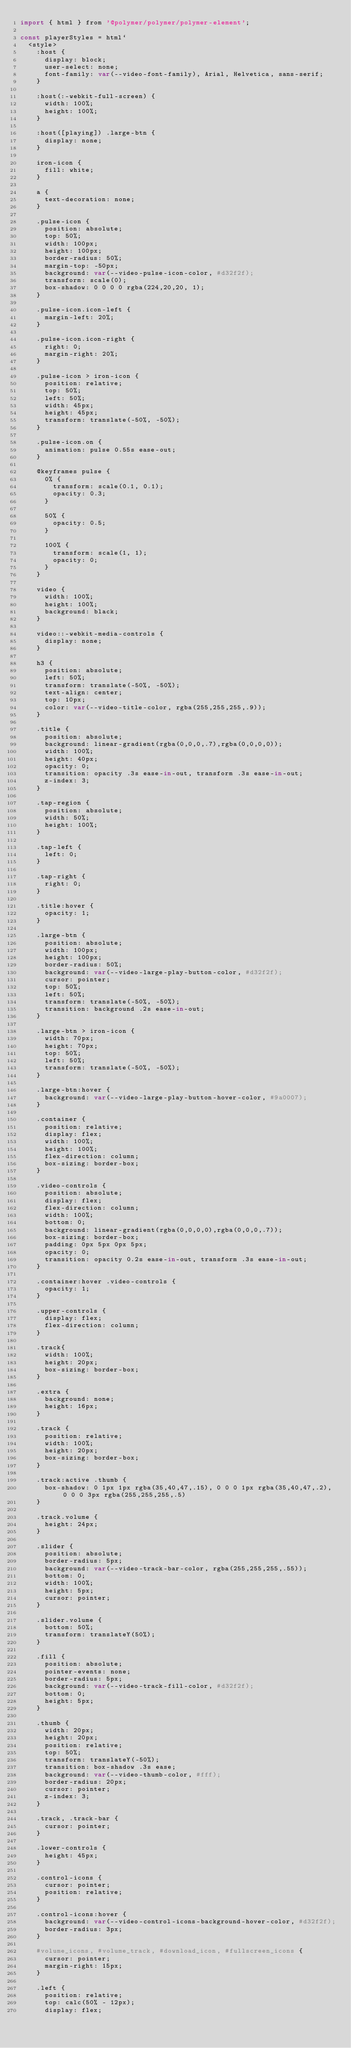Convert code to text. <code><loc_0><loc_0><loc_500><loc_500><_JavaScript_>import { html } from '@polymer/polymer/polymer-element';

const playerStyles = html`
  <style>
    :host {
      display: block;
      user-select: none;
      font-family: var(--video-font-family), Arial, Helvetica, sans-serif;
    }

    :host(:-webkit-full-screen) {
      width: 100%;
      height: 100%;
    }
    
    :host([playing]) .large-btn {
      display: none;
    }

    iron-icon {
      fill: white;
    }

    a {
      text-decoration: none;
    }

    .pulse-icon {
      position: absolute;
      top: 50%;
      width: 100px;
      height: 100px;
      border-radius: 50%;
      margin-top: -50px;
      background: var(--video-pulse-icon-color, #d32f2f);
      transform: scale(0);
      box-shadow: 0 0 0 0 rgba(224,20,20, 1);
    }

    .pulse-icon.icon-left {
      margin-left: 20%;
    }

    .pulse-icon.icon-right {
      right: 0;
      margin-right: 20%;
    }

    .pulse-icon > iron-icon {
      position: relative;
      top: 50%;
      left: 50%;
      width: 45px;
      height: 45px;
      transform: translate(-50%, -50%);
    }

    .pulse-icon.on {
      animation: pulse 0.55s ease-out;
    }

    @keyframes pulse {
      0% {
        transform: scale(0.1, 0.1);
        opacity: 0.3;
      }

      50% {
        opacity: 0.5;
      }

      100% {
        transform: scale(1, 1);
        opacity: 0;
      }
    }

    video {
      width: 100%;
      height: 100%;
      background: black;
    }

    video::-webkit-media-controls {
      display: none;
    }

    h3 {
      position: absolute;
      left: 50%;
      transform: translate(-50%, -50%);
      text-align: center;
      top: 10px;
      color: var(--video-title-color, rgba(255,255,255,.9));
    }

    .title {
      position: absolute;
      background: linear-gradient(rgba(0,0,0,.7),rgba(0,0,0,0));
      width: 100%;
      height: 40px;
      opacity: 0;
      transition: opacity .3s ease-in-out, transform .3s ease-in-out;
      z-index: 3;
    }

    .tap-region {
      position: absolute;
      width: 50%;
      height: 100%;
    }

    .tap-left {
      left: 0;
    }

    .tap-right {
      right: 0;
    }

    .title:hover {
      opacity: 1;
    }

    .large-btn {
      position: absolute;
      width: 100px;
      height: 100px;
      border-radius: 50%;
      background: var(--video-large-play-button-color, #d32f2f);
      cursor: pointer;
      top: 50%;
      left: 50%;
      transform: translate(-50%, -50%);
      transition: background .2s ease-in-out;
    }

    .large-btn > iron-icon {
      width: 70px;
      height: 70px;
      top: 50%;
      left: 50%;
      transform: translate(-50%, -50%);
    }

    .large-btn:hover {
      background: var(--video-large-play-button-hover-color, #9a0007);
    }

    .container {
      position: relative;
      display: flex;
      width: 100%;
      height: 100%;
      flex-direction: column;
      box-sizing: border-box;
    }

    .video-controls {
      position: absolute;
      display: flex;
      flex-direction: column;
      width: 100%;
      bottom: 0;
      background: linear-gradient(rgba(0,0,0,0),rgba(0,0,0,.7));
      box-sizing: border-box;
      padding: 0px 5px 0px 5px;
      opacity: 0;
      transition: opacity 0.2s ease-in-out, transform .3s ease-in-out;
    }

    .container:hover .video-controls {
      opacity: 1;
    }

    .upper-controls {
      display: flex;
      flex-direction: column;
    }

    .track{
      width: 100%;
      height: 20px;
      box-sizing: border-box;
    }

    .extra {
      background: none;
      height: 16px;
    }

    .track {
      position: relative;
      width: 100%;
      height: 20px;
      box-sizing: border-box;
    }

    .track:active .thumb {
      box-shadow: 0 1px 1px rgba(35,40,47,.15), 0 0 0 1px rgba(35,40,47,.2), 0 0 0 3px rgba(255,255,255,.5)
    }

    .track.volume {
      height: 24px;
    }
    
    .slider {
      position: absolute;
      border-radius: 5px;
      background: var(--video-track-bar-color, rgba(255,255,255,.55));
      bottom: 0;
      width: 100%;
      height: 5px;
      cursor: pointer;
    }

    .slider.volume {
      bottom: 50%;
      transform: translateY(50%);
    }
    
    .fill {
      position: absolute;
      pointer-events: none;
      border-radius: 5px;
      background: var(--video-track-fill-color, #d32f2f);
      bottom: 0;
      height: 5px;
    }

    .thumb {
      width: 20px;
      height: 20px;
      position: relative;
      top: 50%;
      transform: translateY(-50%);
      transition: box-shadow .3s ease;
      background: var(--video-thumb-color, #fff);
      border-radius: 20px;
      cursor: pointer;
      z-index: 3;
    }

    .track, .track-bar {
      cursor: pointer;
    }

    .lower-controls {
      height: 45px;
    }

    .control-icons {
      cursor: pointer;
      position: relative;
    }

    .control-icons:hover {
      background: var(--video-control-icons-background-hover-color, #d32f2f);
      border-radius: 3px;
    }

    #volume_icons, #volume_track, #download_icon, #fullscreen_icons {
      cursor: pointer;
      margin-right: 15px;
    }

    .left {
      position: relative;
      top: calc(50% - 12px);
      display: flex;</code> 